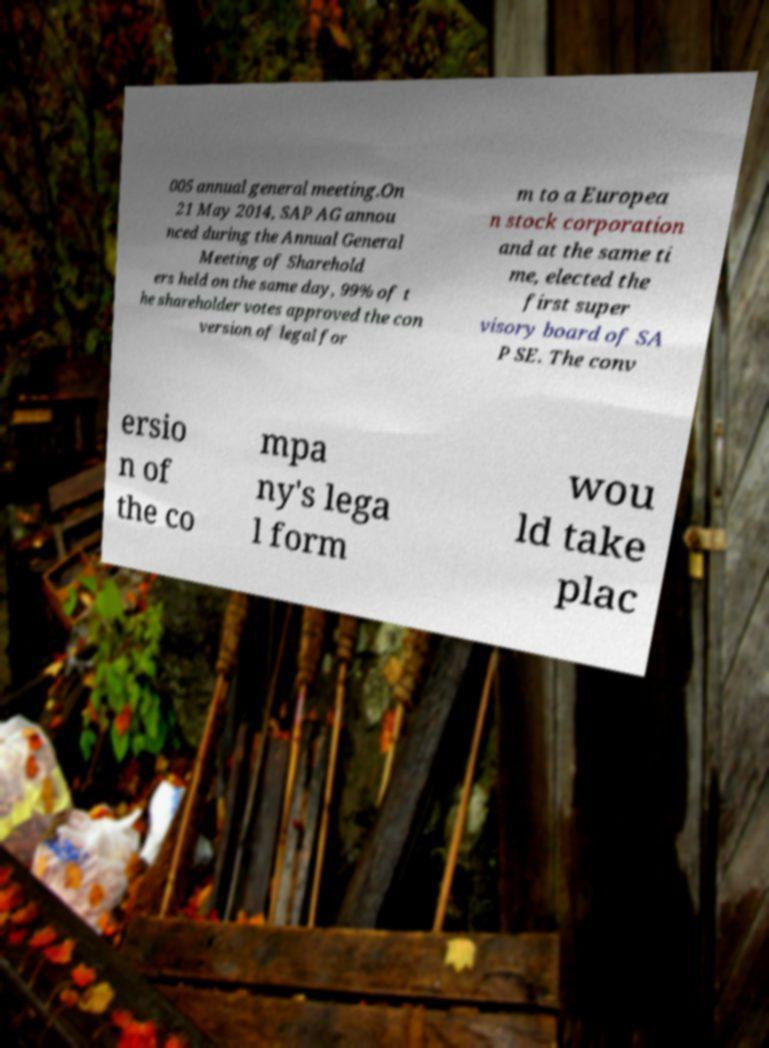Please identify and transcribe the text found in this image. 005 annual general meeting.On 21 May 2014, SAP AG annou nced during the Annual General Meeting of Sharehold ers held on the same day, 99% of t he shareholder votes approved the con version of legal for m to a Europea n stock corporation and at the same ti me, elected the first super visory board of SA P SE. The conv ersio n of the co mpa ny's lega l form wou ld take plac 